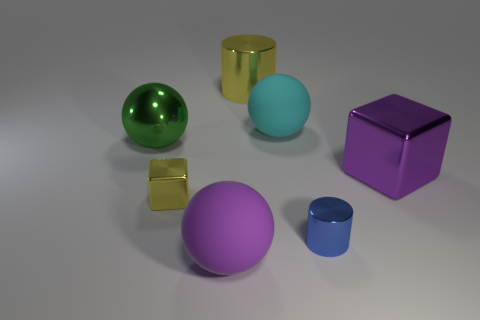What materials do the objects in the image seem to be made of? The objects in the image appear to be constructed from various materials that give them a glossy and reflective surface, suggestive of metals or materials with metallic finishes. 